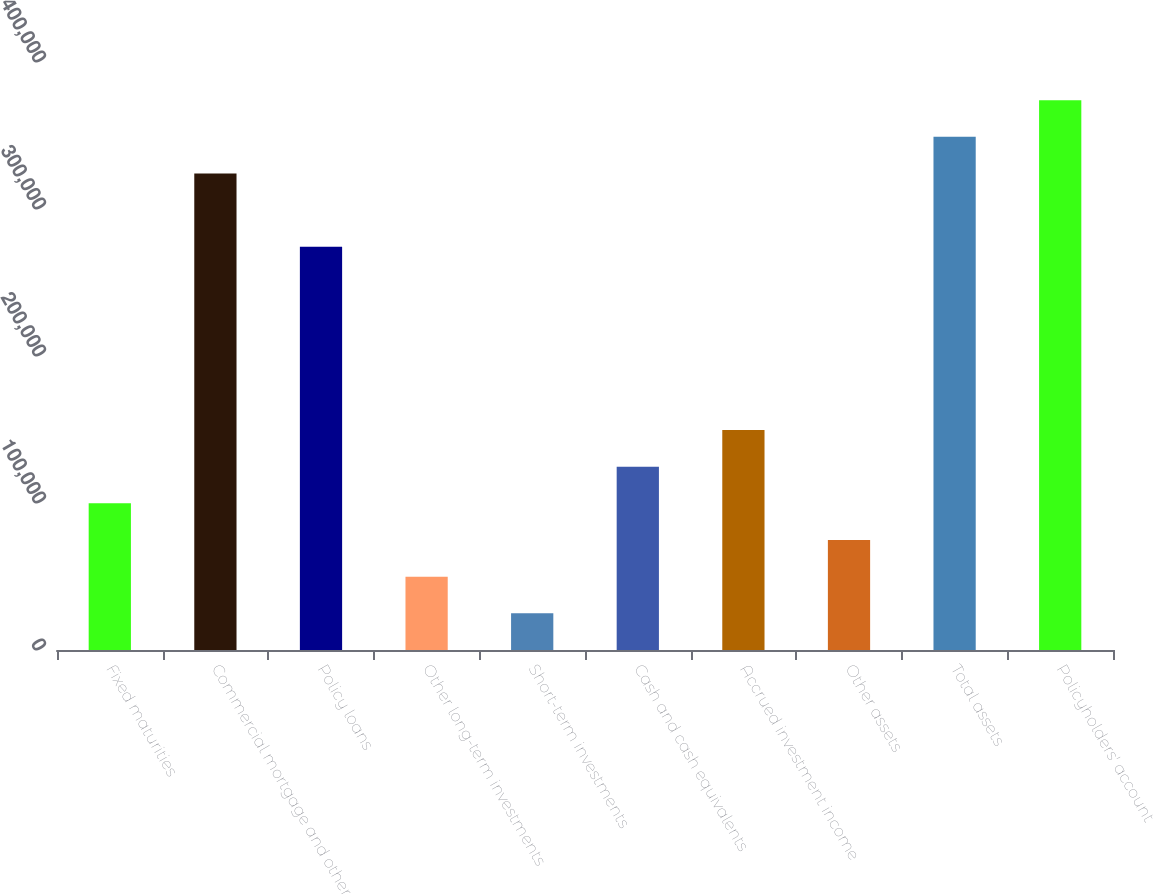Convert chart to OTSL. <chart><loc_0><loc_0><loc_500><loc_500><bar_chart><fcel>Fixed maturities<fcel>Commercial mortgage and other<fcel>Policy loans<fcel>Other long-term investments<fcel>Short-term investments<fcel>Cash and cash equivalents<fcel>Accrued investment income<fcel>Other assets<fcel>Total assets<fcel>Policyholders' account<nl><fcel>99756.8<fcel>324169<fcel>274300<fcel>49887.4<fcel>24952.7<fcel>124692<fcel>149626<fcel>74822.1<fcel>349104<fcel>374038<nl></chart> 